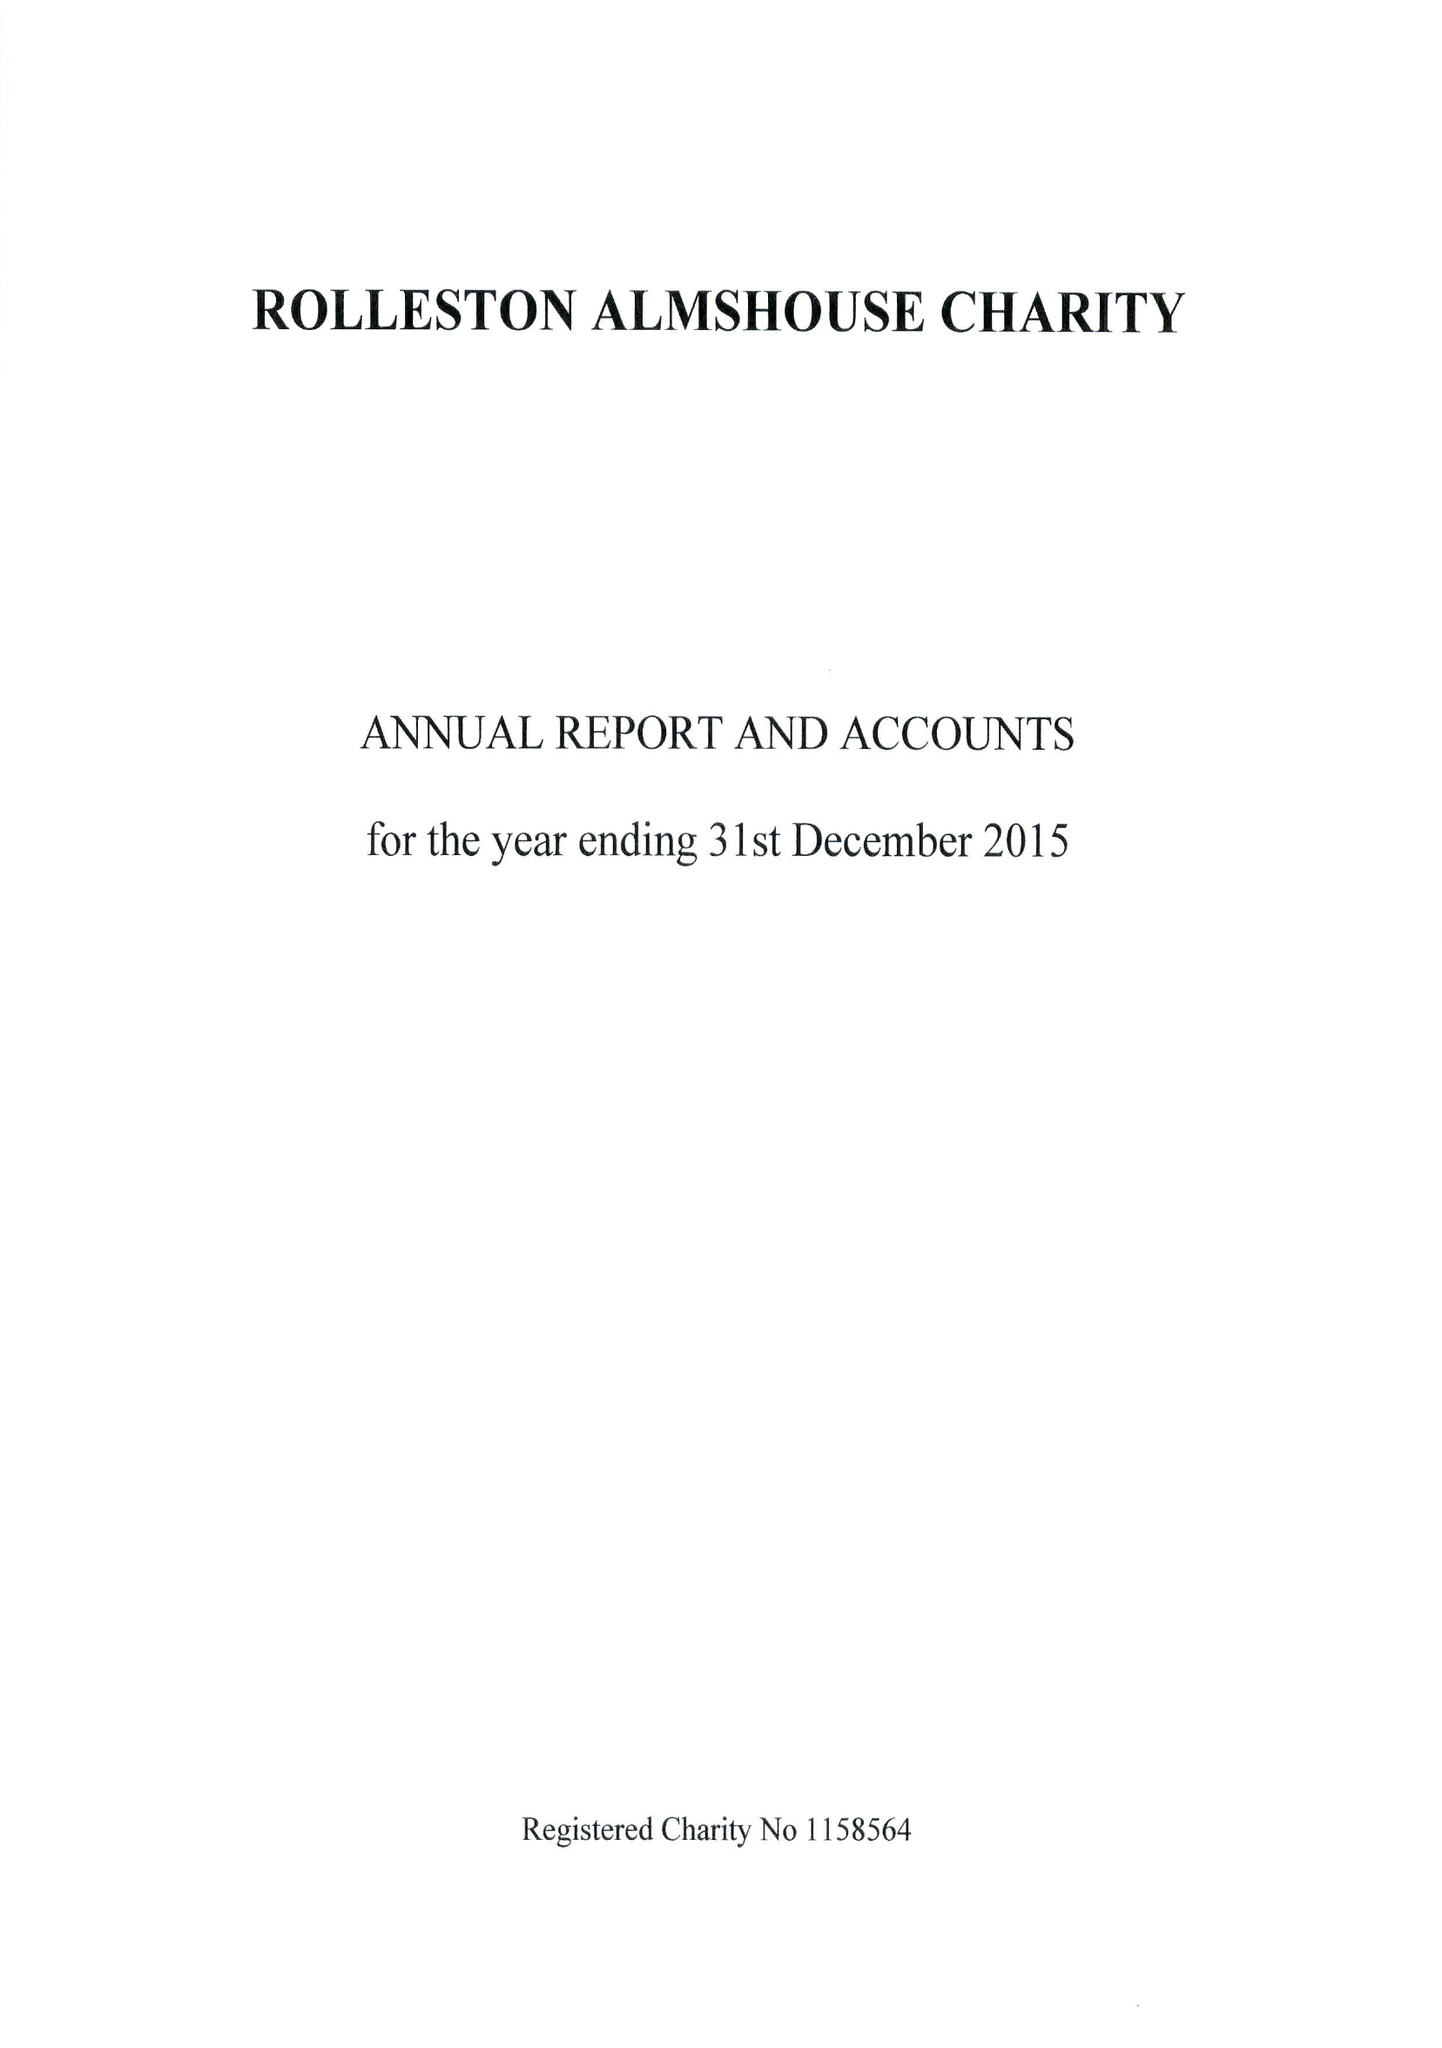What is the value for the address__post_town?
Answer the question using a single word or phrase. BURTON-ON-TRENT 